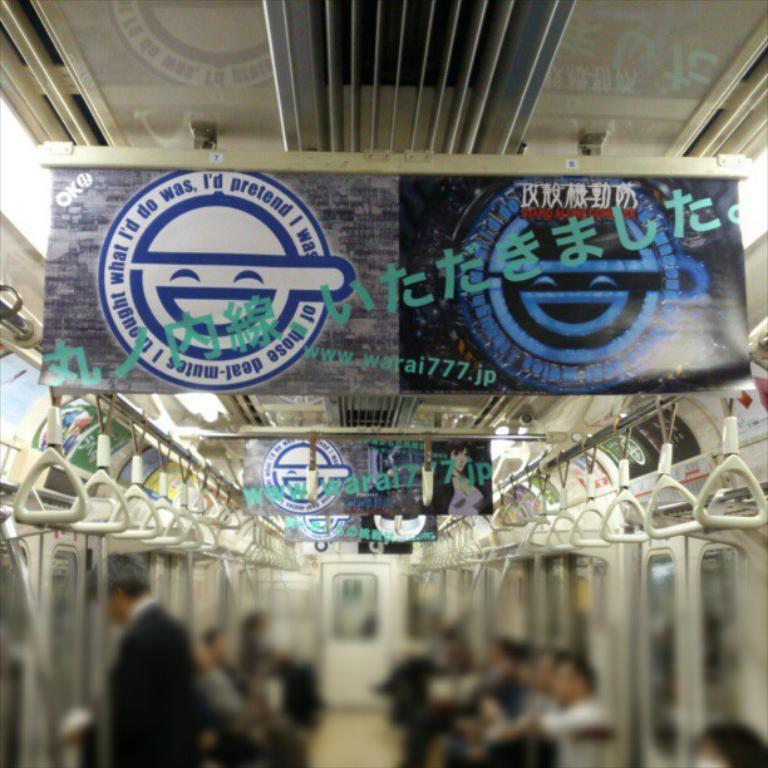What type of vehicle is shown in the image? The image shows an inner view of a train. What are the people in the image doing? There are people sitting in the train. What can be seen on the wall of the train? There is a board visible in the train. What is above the people in the image? There is a roof in the train. How does the beginner learn to rest in the image? There is no mention of a beginner or learning to rest in the image; it simply shows an inner view of a train with people sitting inside. 